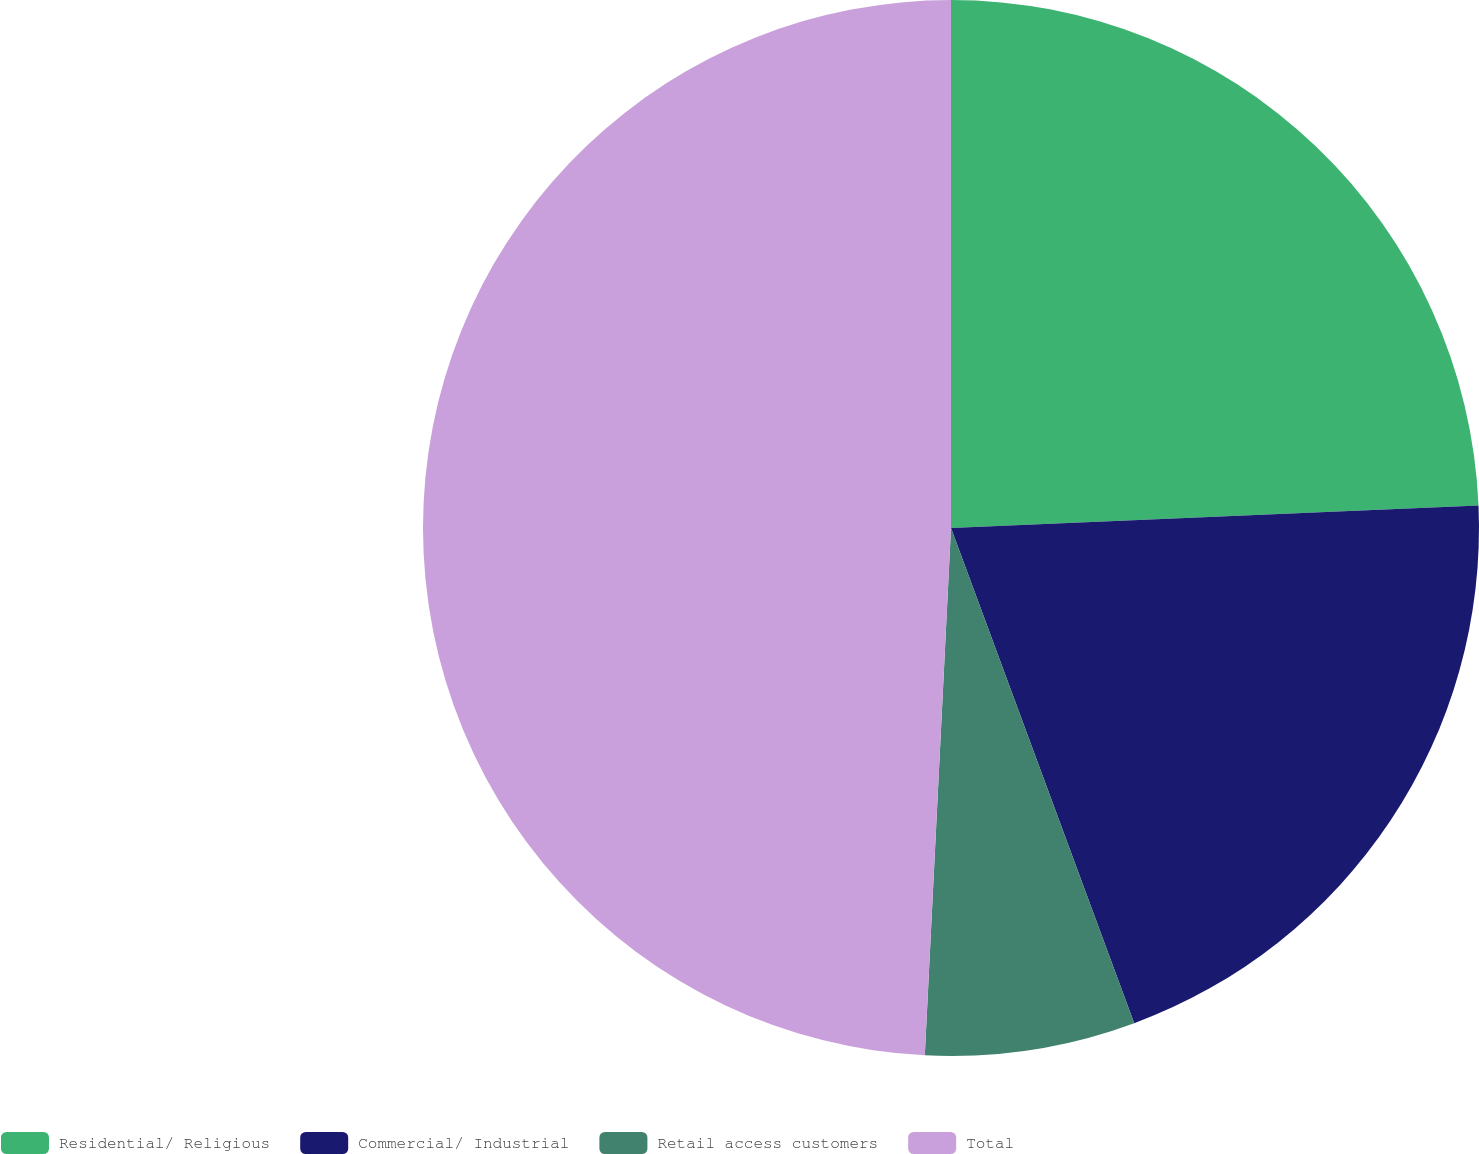Convert chart. <chart><loc_0><loc_0><loc_500><loc_500><pie_chart><fcel>Residential/ Religious<fcel>Commercial/ Industrial<fcel>Retail access customers<fcel>Total<nl><fcel>24.32%<fcel>20.04%<fcel>6.43%<fcel>49.21%<nl></chart> 